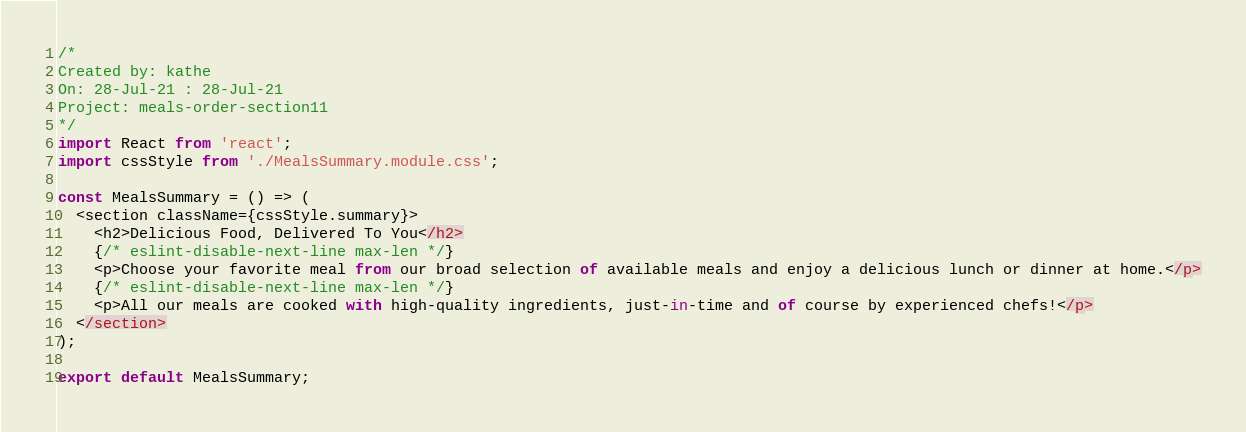Convert code to text. <code><loc_0><loc_0><loc_500><loc_500><_JavaScript_>/*
Created by: kathe
On: 28-Jul-21 : 28-Jul-21
Project: meals-order-section11
*/
import React from 'react';
import cssStyle from './MealsSummary.module.css';

const MealsSummary = () => (
  <section className={cssStyle.summary}>
    <h2>Delicious Food, Delivered To You</h2>
    {/* eslint-disable-next-line max-len */}
    <p>Choose your favorite meal from our broad selection of available meals and enjoy a delicious lunch or dinner at home.</p>
    {/* eslint-disable-next-line max-len */}
    <p>All our meals are cooked with high-quality ingredients, just-in-time and of course by experienced chefs!</p>
  </section>
);

export default MealsSummary;
</code> 